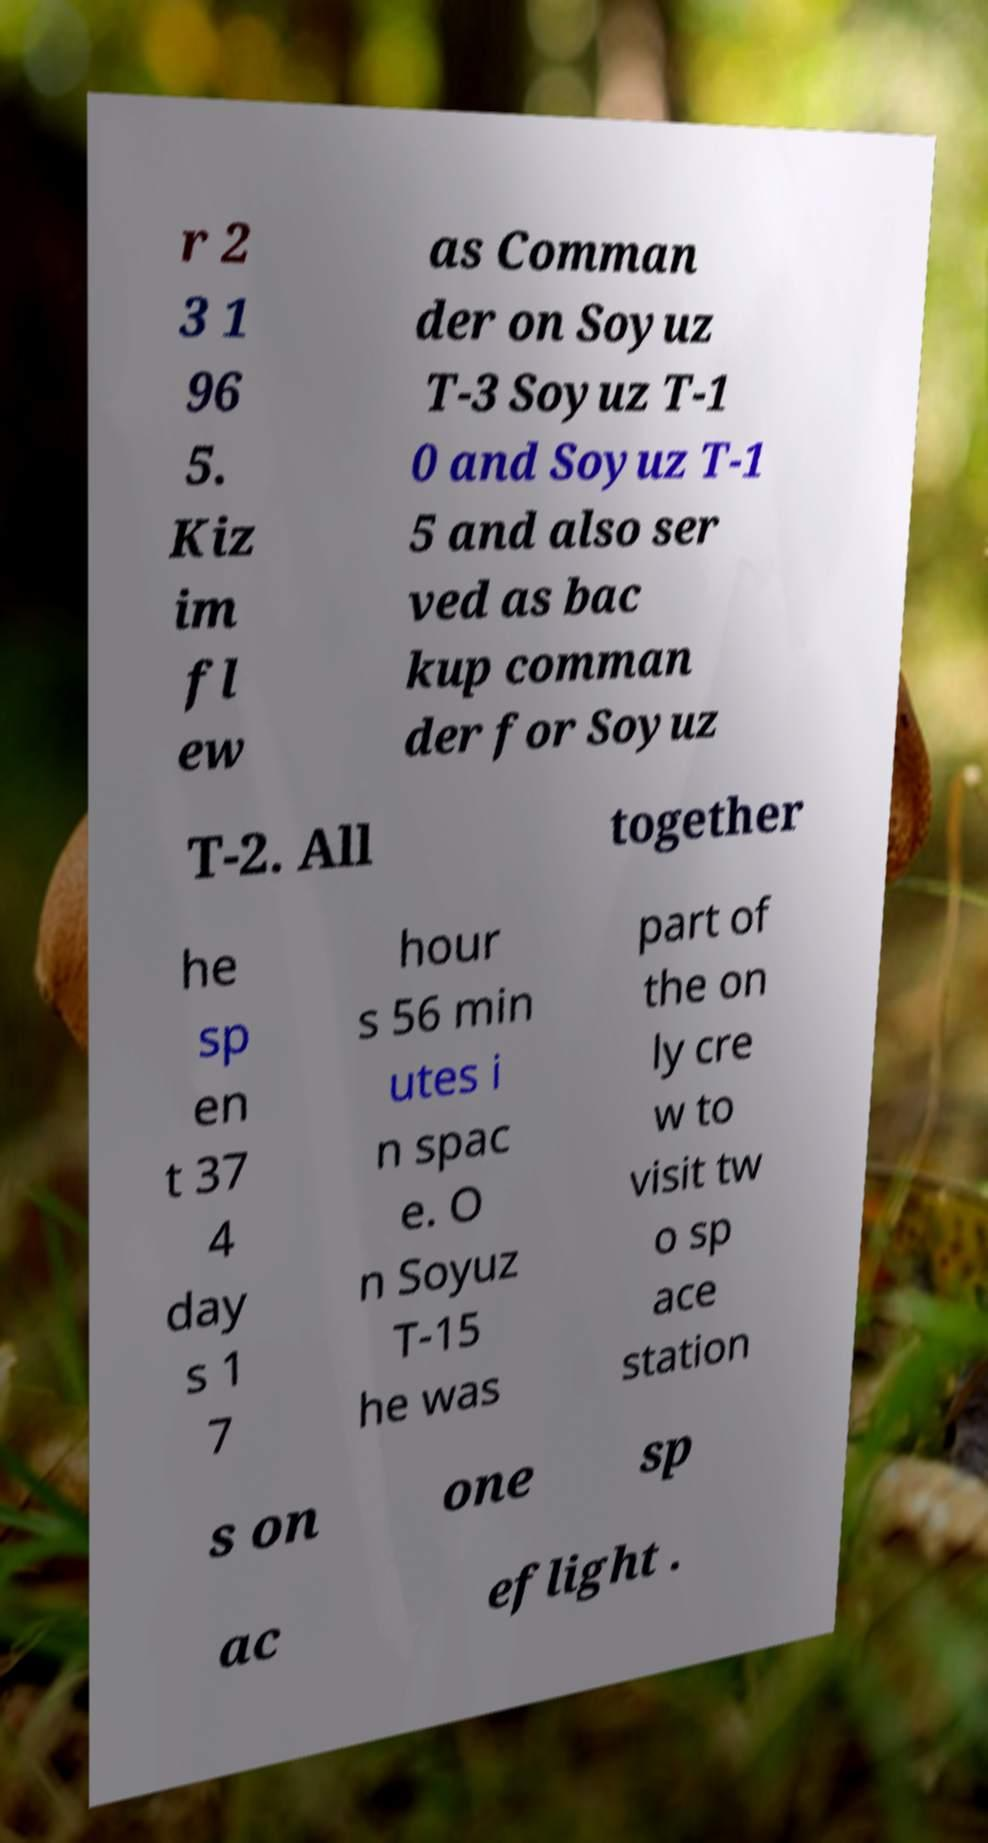Can you accurately transcribe the text from the provided image for me? r 2 3 1 96 5. Kiz im fl ew as Comman der on Soyuz T-3 Soyuz T-1 0 and Soyuz T-1 5 and also ser ved as bac kup comman der for Soyuz T-2. All together he sp en t 37 4 day s 1 7 hour s 56 min utes i n spac e. O n Soyuz T-15 he was part of the on ly cre w to visit tw o sp ace station s on one sp ac eflight . 